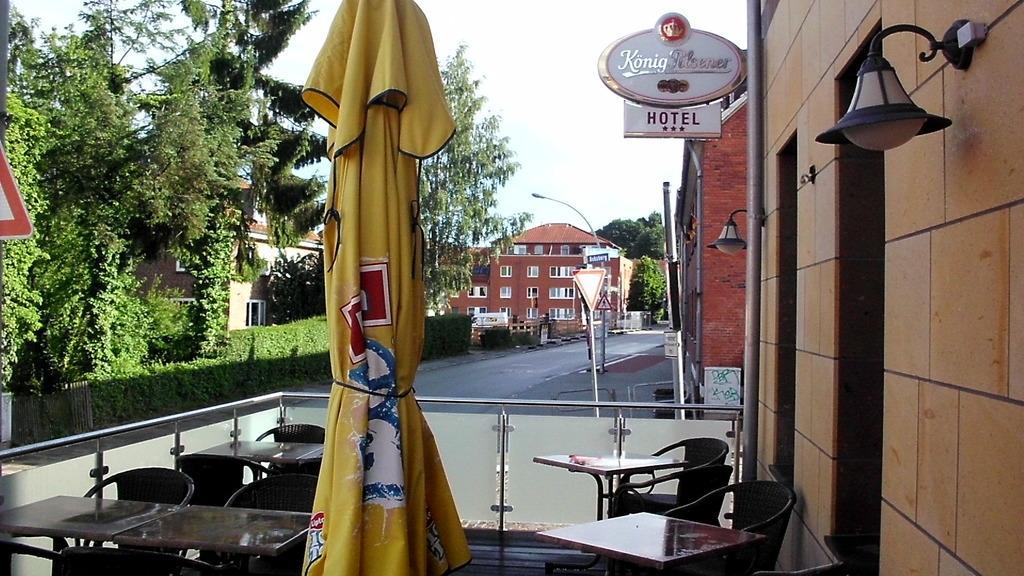Describe this image in one or two sentences. In this image I can see chairs,tables and yellow color cloth. Back I can see buildings,windows,signboards,light-poles and trees. The sky is in white color. 